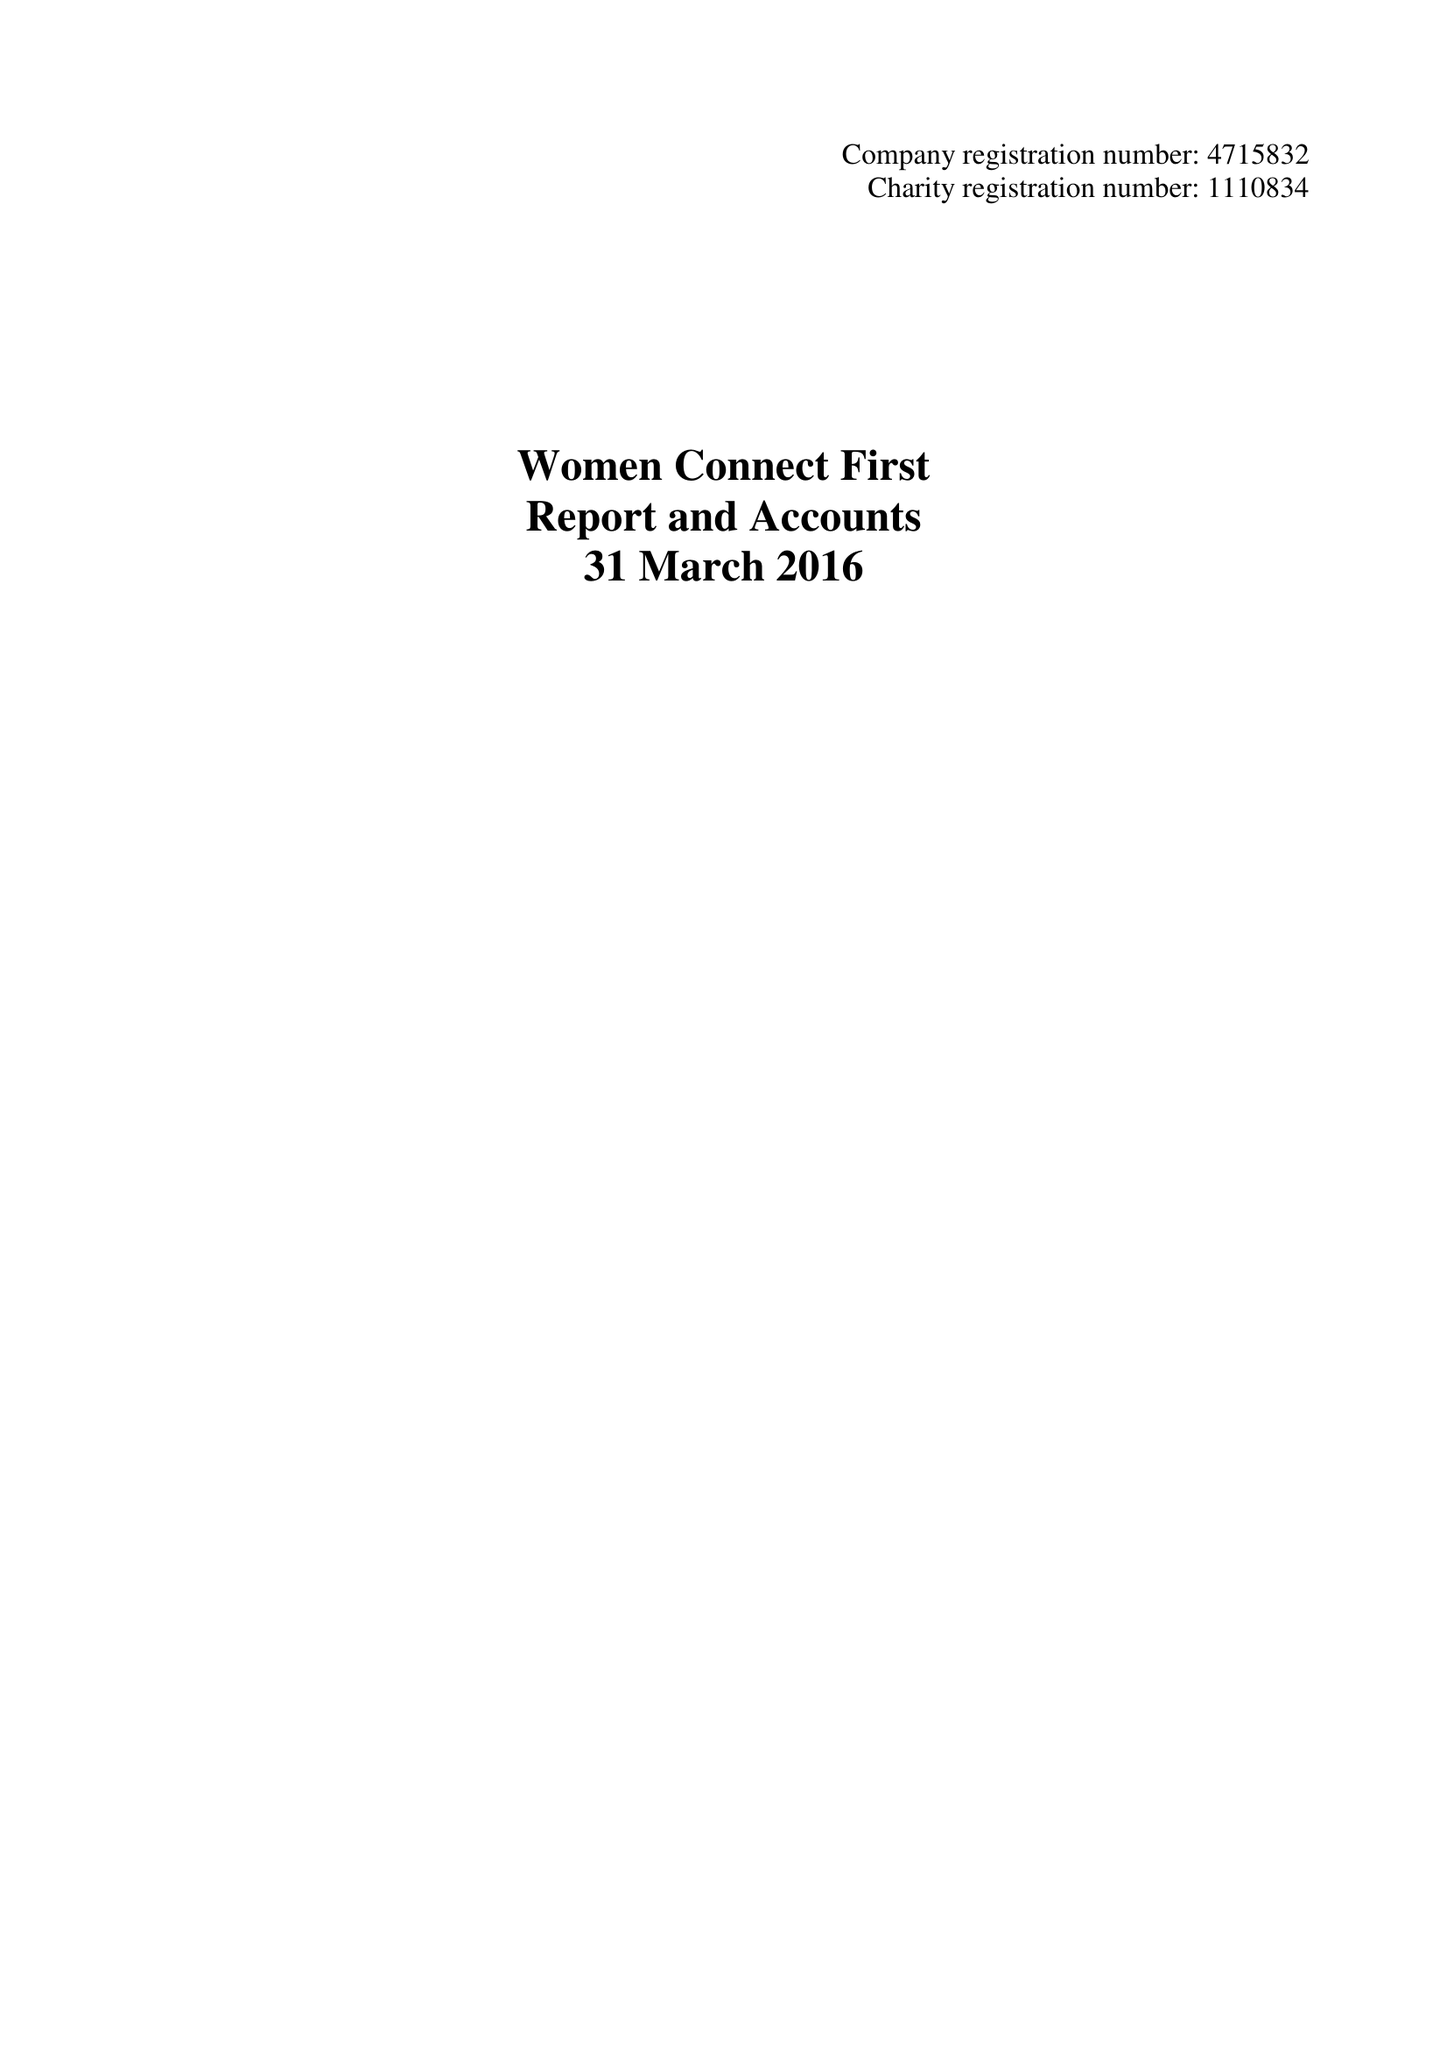What is the value for the charity_number?
Answer the question using a single word or phrase. 1110834 